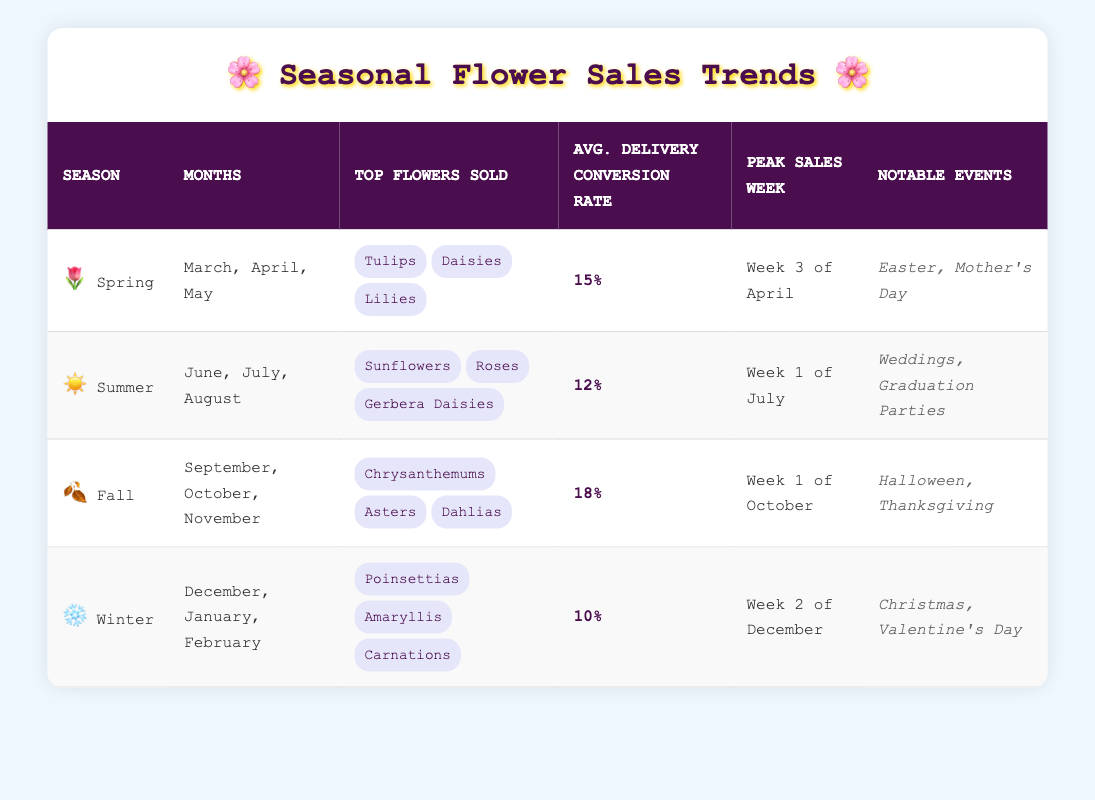What are the top flowers sold in Spring? The table specifies that the top flowers sold in Spring are Tulips, Daisies, and Lilies. These flowers are listed directly under the "Top Flowers Sold" column for Spring.
Answer: Tulips, Daisies, Lilies Which season has the highest average delivery conversion rate? According to the table, the average delivery conversion rates are 15% for Spring, 12% for Summer, 18% for Fall, and 10% for Winter. The highest value is 18%, which corresponds to Fall.
Answer: Fall During which month does peak sales occur in Winter? The table indicates that peak sales for Winter happen in Week 2 of December. This information is found directly under the "Peak Sales Week" column for the Winter season.
Answer: Week 2 of December What is the difference in average delivery conversion rates between Fall and Winter? The average delivery conversion rate for Fall is 18% and for Winter it is 10%. The difference is calculated as 18% - 10% = 8%.
Answer: 8% Is Mother's Day a notable event in Spring? The table lists notable events for Spring, which include Easter and Mother's Day. Since Mother's Day is included in this list, the answer is yes.
Answer: Yes Which season has the lowest average delivery conversion rate? The table shows the average delivery conversion rates: 15% for Spring, 12% for Summer, 18% for Fall, and 10% for Winter. The lowest value is 10%, corresponding to Winter.
Answer: Winter How many notable events are listed for Summer? In the table, Summer has two notable events listed: Weddings and Graduation Parties. This count can be determined by simply listing and counting the items in the "Notable Events" column for Summer.
Answer: 2 If we add the average delivery conversion rates for all seasons, what would that total be? Summing the average delivery conversion rates: 15% (Spring) + 12% (Summer) + 18% (Fall) + 10% (Winter) = 55%. Therefore, the total is 55%.
Answer: 55 What is the top flower sold during Summer? The table specifies that the top flowers sold in Summer include Sunflowers, Roses, and Gerbera Daisies. The first flower listed, Sunflowers, is the answer to this question.
Answer: Sunflowers Which season has notable events related to Halloween? The table indicates that Halloween is a notable event in Fall, as that is the season mentioned under the "Notable Events" column.
Answer: Fall 